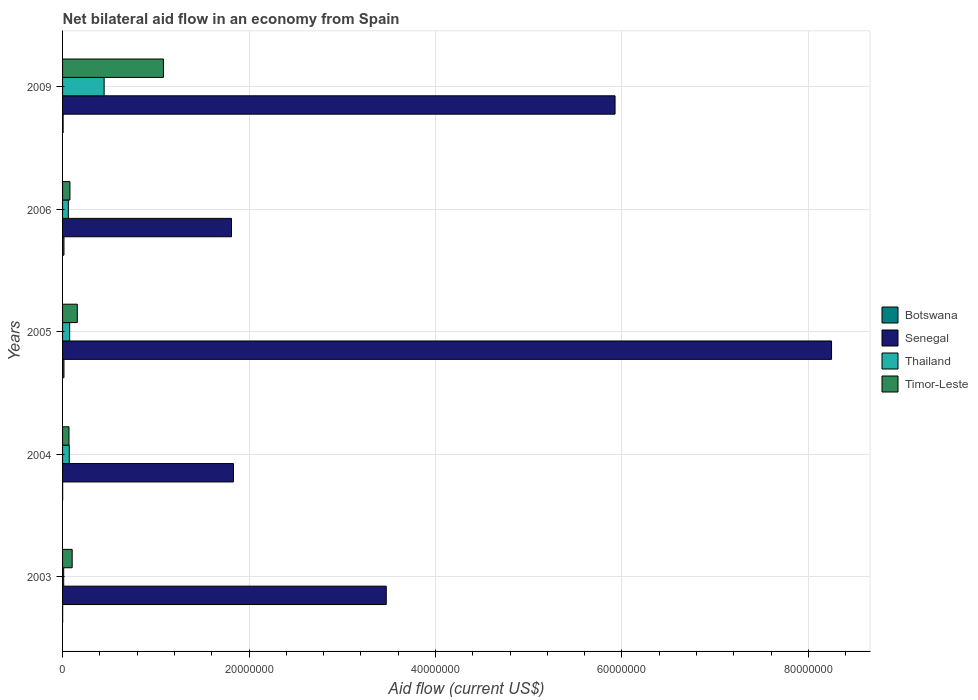How many groups of bars are there?
Provide a succinct answer. 5. Are the number of bars per tick equal to the number of legend labels?
Your response must be concise. Yes. Are the number of bars on each tick of the Y-axis equal?
Your answer should be compact. Yes. How many bars are there on the 5th tick from the top?
Offer a very short reply. 4. What is the net bilateral aid flow in Senegal in 2005?
Give a very brief answer. 8.25e+07. Across all years, what is the maximum net bilateral aid flow in Timor-Leste?
Keep it short and to the point. 1.08e+07. Across all years, what is the minimum net bilateral aid flow in Senegal?
Keep it short and to the point. 1.81e+07. What is the total net bilateral aid flow in Botswana in the graph?
Ensure brevity in your answer.  3.80e+05. What is the difference between the net bilateral aid flow in Senegal in 2006 and that in 2009?
Offer a terse response. -4.11e+07. What is the difference between the net bilateral aid flow in Thailand in 2009 and the net bilateral aid flow in Timor-Leste in 2003?
Your answer should be very brief. 3.43e+06. What is the average net bilateral aid flow in Senegal per year?
Your answer should be very brief. 4.26e+07. In the year 2005, what is the difference between the net bilateral aid flow in Senegal and net bilateral aid flow in Thailand?
Keep it short and to the point. 8.17e+07. What is the ratio of the net bilateral aid flow in Senegal in 2003 to that in 2006?
Offer a very short reply. 1.92. Is the net bilateral aid flow in Thailand in 2003 less than that in 2005?
Offer a terse response. Yes. Is the difference between the net bilateral aid flow in Senegal in 2003 and 2009 greater than the difference between the net bilateral aid flow in Thailand in 2003 and 2009?
Make the answer very short. No. What is the difference between the highest and the second highest net bilateral aid flow in Senegal?
Offer a very short reply. 2.32e+07. What is the difference between the highest and the lowest net bilateral aid flow in Timor-Leste?
Ensure brevity in your answer.  1.01e+07. In how many years, is the net bilateral aid flow in Timor-Leste greater than the average net bilateral aid flow in Timor-Leste taken over all years?
Provide a succinct answer. 1. Is it the case that in every year, the sum of the net bilateral aid flow in Botswana and net bilateral aid flow in Timor-Leste is greater than the sum of net bilateral aid flow in Senegal and net bilateral aid flow in Thailand?
Ensure brevity in your answer.  No. What does the 2nd bar from the top in 2004 represents?
Your answer should be compact. Thailand. What does the 1st bar from the bottom in 2004 represents?
Make the answer very short. Botswana. How many years are there in the graph?
Offer a very short reply. 5. What is the difference between two consecutive major ticks on the X-axis?
Offer a terse response. 2.00e+07. Are the values on the major ticks of X-axis written in scientific E-notation?
Give a very brief answer. No. How are the legend labels stacked?
Provide a succinct answer. Vertical. What is the title of the graph?
Make the answer very short. Net bilateral aid flow in an economy from Spain. Does "Sri Lanka" appear as one of the legend labels in the graph?
Your answer should be very brief. No. What is the label or title of the X-axis?
Ensure brevity in your answer.  Aid flow (current US$). What is the Aid flow (current US$) in Botswana in 2003?
Your response must be concise. 10000. What is the Aid flow (current US$) in Senegal in 2003?
Keep it short and to the point. 3.47e+07. What is the Aid flow (current US$) in Timor-Leste in 2003?
Ensure brevity in your answer.  1.03e+06. What is the Aid flow (current US$) of Senegal in 2004?
Provide a short and direct response. 1.83e+07. What is the Aid flow (current US$) of Thailand in 2004?
Provide a succinct answer. 7.20e+05. What is the Aid flow (current US$) in Timor-Leste in 2004?
Ensure brevity in your answer.  6.90e+05. What is the Aid flow (current US$) in Botswana in 2005?
Your answer should be compact. 1.50e+05. What is the Aid flow (current US$) of Senegal in 2005?
Offer a terse response. 8.25e+07. What is the Aid flow (current US$) in Thailand in 2005?
Offer a very short reply. 7.60e+05. What is the Aid flow (current US$) in Timor-Leste in 2005?
Make the answer very short. 1.58e+06. What is the Aid flow (current US$) of Senegal in 2006?
Provide a succinct answer. 1.81e+07. What is the Aid flow (current US$) in Thailand in 2006?
Your answer should be compact. 6.20e+05. What is the Aid flow (current US$) in Timor-Leste in 2006?
Give a very brief answer. 7.90e+05. What is the Aid flow (current US$) in Senegal in 2009?
Make the answer very short. 5.93e+07. What is the Aid flow (current US$) in Thailand in 2009?
Offer a terse response. 4.46e+06. What is the Aid flow (current US$) of Timor-Leste in 2009?
Your answer should be very brief. 1.08e+07. Across all years, what is the maximum Aid flow (current US$) of Botswana?
Ensure brevity in your answer.  1.50e+05. Across all years, what is the maximum Aid flow (current US$) in Senegal?
Provide a succinct answer. 8.25e+07. Across all years, what is the maximum Aid flow (current US$) of Thailand?
Ensure brevity in your answer.  4.46e+06. Across all years, what is the maximum Aid flow (current US$) in Timor-Leste?
Offer a terse response. 1.08e+07. Across all years, what is the minimum Aid flow (current US$) in Senegal?
Your answer should be compact. 1.81e+07. Across all years, what is the minimum Aid flow (current US$) of Thailand?
Make the answer very short. 1.20e+05. Across all years, what is the minimum Aid flow (current US$) in Timor-Leste?
Your answer should be compact. 6.90e+05. What is the total Aid flow (current US$) of Botswana in the graph?
Provide a succinct answer. 3.80e+05. What is the total Aid flow (current US$) in Senegal in the graph?
Provide a short and direct response. 2.13e+08. What is the total Aid flow (current US$) of Thailand in the graph?
Ensure brevity in your answer.  6.68e+06. What is the total Aid flow (current US$) of Timor-Leste in the graph?
Keep it short and to the point. 1.49e+07. What is the difference between the Aid flow (current US$) of Senegal in 2003 and that in 2004?
Your answer should be very brief. 1.64e+07. What is the difference between the Aid flow (current US$) in Thailand in 2003 and that in 2004?
Your response must be concise. -6.00e+05. What is the difference between the Aid flow (current US$) of Timor-Leste in 2003 and that in 2004?
Your response must be concise. 3.40e+05. What is the difference between the Aid flow (current US$) of Botswana in 2003 and that in 2005?
Your answer should be very brief. -1.40e+05. What is the difference between the Aid flow (current US$) in Senegal in 2003 and that in 2005?
Offer a terse response. -4.78e+07. What is the difference between the Aid flow (current US$) in Thailand in 2003 and that in 2005?
Make the answer very short. -6.40e+05. What is the difference between the Aid flow (current US$) of Timor-Leste in 2003 and that in 2005?
Give a very brief answer. -5.50e+05. What is the difference between the Aid flow (current US$) in Botswana in 2003 and that in 2006?
Offer a terse response. -1.40e+05. What is the difference between the Aid flow (current US$) of Senegal in 2003 and that in 2006?
Provide a succinct answer. 1.66e+07. What is the difference between the Aid flow (current US$) in Thailand in 2003 and that in 2006?
Ensure brevity in your answer.  -5.00e+05. What is the difference between the Aid flow (current US$) in Timor-Leste in 2003 and that in 2006?
Your answer should be compact. 2.40e+05. What is the difference between the Aid flow (current US$) of Senegal in 2003 and that in 2009?
Provide a succinct answer. -2.45e+07. What is the difference between the Aid flow (current US$) of Thailand in 2003 and that in 2009?
Provide a succinct answer. -4.34e+06. What is the difference between the Aid flow (current US$) in Timor-Leste in 2003 and that in 2009?
Your answer should be compact. -9.79e+06. What is the difference between the Aid flow (current US$) in Botswana in 2004 and that in 2005?
Ensure brevity in your answer.  -1.40e+05. What is the difference between the Aid flow (current US$) of Senegal in 2004 and that in 2005?
Keep it short and to the point. -6.42e+07. What is the difference between the Aid flow (current US$) in Thailand in 2004 and that in 2005?
Provide a succinct answer. -4.00e+04. What is the difference between the Aid flow (current US$) of Timor-Leste in 2004 and that in 2005?
Give a very brief answer. -8.90e+05. What is the difference between the Aid flow (current US$) in Timor-Leste in 2004 and that in 2006?
Provide a succinct answer. -1.00e+05. What is the difference between the Aid flow (current US$) in Senegal in 2004 and that in 2009?
Make the answer very short. -4.09e+07. What is the difference between the Aid flow (current US$) of Thailand in 2004 and that in 2009?
Your answer should be very brief. -3.74e+06. What is the difference between the Aid flow (current US$) of Timor-Leste in 2004 and that in 2009?
Make the answer very short. -1.01e+07. What is the difference between the Aid flow (current US$) of Botswana in 2005 and that in 2006?
Your answer should be compact. 0. What is the difference between the Aid flow (current US$) of Senegal in 2005 and that in 2006?
Make the answer very short. 6.44e+07. What is the difference between the Aid flow (current US$) in Timor-Leste in 2005 and that in 2006?
Offer a very short reply. 7.90e+05. What is the difference between the Aid flow (current US$) of Botswana in 2005 and that in 2009?
Provide a short and direct response. 9.00e+04. What is the difference between the Aid flow (current US$) in Senegal in 2005 and that in 2009?
Your response must be concise. 2.32e+07. What is the difference between the Aid flow (current US$) of Thailand in 2005 and that in 2009?
Keep it short and to the point. -3.70e+06. What is the difference between the Aid flow (current US$) in Timor-Leste in 2005 and that in 2009?
Provide a succinct answer. -9.24e+06. What is the difference between the Aid flow (current US$) of Senegal in 2006 and that in 2009?
Your answer should be compact. -4.11e+07. What is the difference between the Aid flow (current US$) of Thailand in 2006 and that in 2009?
Your response must be concise. -3.84e+06. What is the difference between the Aid flow (current US$) of Timor-Leste in 2006 and that in 2009?
Provide a short and direct response. -1.00e+07. What is the difference between the Aid flow (current US$) in Botswana in 2003 and the Aid flow (current US$) in Senegal in 2004?
Offer a very short reply. -1.83e+07. What is the difference between the Aid flow (current US$) in Botswana in 2003 and the Aid flow (current US$) in Thailand in 2004?
Provide a short and direct response. -7.10e+05. What is the difference between the Aid flow (current US$) of Botswana in 2003 and the Aid flow (current US$) of Timor-Leste in 2004?
Provide a short and direct response. -6.80e+05. What is the difference between the Aid flow (current US$) in Senegal in 2003 and the Aid flow (current US$) in Thailand in 2004?
Make the answer very short. 3.40e+07. What is the difference between the Aid flow (current US$) of Senegal in 2003 and the Aid flow (current US$) of Timor-Leste in 2004?
Your answer should be very brief. 3.40e+07. What is the difference between the Aid flow (current US$) of Thailand in 2003 and the Aid flow (current US$) of Timor-Leste in 2004?
Offer a terse response. -5.70e+05. What is the difference between the Aid flow (current US$) in Botswana in 2003 and the Aid flow (current US$) in Senegal in 2005?
Offer a terse response. -8.25e+07. What is the difference between the Aid flow (current US$) of Botswana in 2003 and the Aid flow (current US$) of Thailand in 2005?
Offer a terse response. -7.50e+05. What is the difference between the Aid flow (current US$) of Botswana in 2003 and the Aid flow (current US$) of Timor-Leste in 2005?
Give a very brief answer. -1.57e+06. What is the difference between the Aid flow (current US$) of Senegal in 2003 and the Aid flow (current US$) of Thailand in 2005?
Give a very brief answer. 3.40e+07. What is the difference between the Aid flow (current US$) in Senegal in 2003 and the Aid flow (current US$) in Timor-Leste in 2005?
Ensure brevity in your answer.  3.31e+07. What is the difference between the Aid flow (current US$) in Thailand in 2003 and the Aid flow (current US$) in Timor-Leste in 2005?
Give a very brief answer. -1.46e+06. What is the difference between the Aid flow (current US$) of Botswana in 2003 and the Aid flow (current US$) of Senegal in 2006?
Provide a succinct answer. -1.81e+07. What is the difference between the Aid flow (current US$) in Botswana in 2003 and the Aid flow (current US$) in Thailand in 2006?
Your answer should be very brief. -6.10e+05. What is the difference between the Aid flow (current US$) of Botswana in 2003 and the Aid flow (current US$) of Timor-Leste in 2006?
Ensure brevity in your answer.  -7.80e+05. What is the difference between the Aid flow (current US$) in Senegal in 2003 and the Aid flow (current US$) in Thailand in 2006?
Provide a short and direct response. 3.41e+07. What is the difference between the Aid flow (current US$) of Senegal in 2003 and the Aid flow (current US$) of Timor-Leste in 2006?
Offer a terse response. 3.39e+07. What is the difference between the Aid flow (current US$) in Thailand in 2003 and the Aid flow (current US$) in Timor-Leste in 2006?
Your response must be concise. -6.70e+05. What is the difference between the Aid flow (current US$) of Botswana in 2003 and the Aid flow (current US$) of Senegal in 2009?
Provide a succinct answer. -5.92e+07. What is the difference between the Aid flow (current US$) of Botswana in 2003 and the Aid flow (current US$) of Thailand in 2009?
Provide a succinct answer. -4.45e+06. What is the difference between the Aid flow (current US$) in Botswana in 2003 and the Aid flow (current US$) in Timor-Leste in 2009?
Make the answer very short. -1.08e+07. What is the difference between the Aid flow (current US$) in Senegal in 2003 and the Aid flow (current US$) in Thailand in 2009?
Ensure brevity in your answer.  3.03e+07. What is the difference between the Aid flow (current US$) of Senegal in 2003 and the Aid flow (current US$) of Timor-Leste in 2009?
Your answer should be compact. 2.39e+07. What is the difference between the Aid flow (current US$) of Thailand in 2003 and the Aid flow (current US$) of Timor-Leste in 2009?
Ensure brevity in your answer.  -1.07e+07. What is the difference between the Aid flow (current US$) in Botswana in 2004 and the Aid flow (current US$) in Senegal in 2005?
Provide a short and direct response. -8.25e+07. What is the difference between the Aid flow (current US$) of Botswana in 2004 and the Aid flow (current US$) of Thailand in 2005?
Offer a very short reply. -7.50e+05. What is the difference between the Aid flow (current US$) of Botswana in 2004 and the Aid flow (current US$) of Timor-Leste in 2005?
Keep it short and to the point. -1.57e+06. What is the difference between the Aid flow (current US$) of Senegal in 2004 and the Aid flow (current US$) of Thailand in 2005?
Provide a succinct answer. 1.76e+07. What is the difference between the Aid flow (current US$) in Senegal in 2004 and the Aid flow (current US$) in Timor-Leste in 2005?
Your answer should be very brief. 1.68e+07. What is the difference between the Aid flow (current US$) in Thailand in 2004 and the Aid flow (current US$) in Timor-Leste in 2005?
Make the answer very short. -8.60e+05. What is the difference between the Aid flow (current US$) in Botswana in 2004 and the Aid flow (current US$) in Senegal in 2006?
Make the answer very short. -1.81e+07. What is the difference between the Aid flow (current US$) of Botswana in 2004 and the Aid flow (current US$) of Thailand in 2006?
Provide a short and direct response. -6.10e+05. What is the difference between the Aid flow (current US$) of Botswana in 2004 and the Aid flow (current US$) of Timor-Leste in 2006?
Ensure brevity in your answer.  -7.80e+05. What is the difference between the Aid flow (current US$) in Senegal in 2004 and the Aid flow (current US$) in Thailand in 2006?
Your response must be concise. 1.77e+07. What is the difference between the Aid flow (current US$) in Senegal in 2004 and the Aid flow (current US$) in Timor-Leste in 2006?
Offer a terse response. 1.75e+07. What is the difference between the Aid flow (current US$) in Thailand in 2004 and the Aid flow (current US$) in Timor-Leste in 2006?
Ensure brevity in your answer.  -7.00e+04. What is the difference between the Aid flow (current US$) of Botswana in 2004 and the Aid flow (current US$) of Senegal in 2009?
Your answer should be very brief. -5.92e+07. What is the difference between the Aid flow (current US$) of Botswana in 2004 and the Aid flow (current US$) of Thailand in 2009?
Give a very brief answer. -4.45e+06. What is the difference between the Aid flow (current US$) in Botswana in 2004 and the Aid flow (current US$) in Timor-Leste in 2009?
Your answer should be very brief. -1.08e+07. What is the difference between the Aid flow (current US$) of Senegal in 2004 and the Aid flow (current US$) of Thailand in 2009?
Keep it short and to the point. 1.39e+07. What is the difference between the Aid flow (current US$) in Senegal in 2004 and the Aid flow (current US$) in Timor-Leste in 2009?
Ensure brevity in your answer.  7.51e+06. What is the difference between the Aid flow (current US$) in Thailand in 2004 and the Aid flow (current US$) in Timor-Leste in 2009?
Provide a succinct answer. -1.01e+07. What is the difference between the Aid flow (current US$) of Botswana in 2005 and the Aid flow (current US$) of Senegal in 2006?
Your answer should be compact. -1.80e+07. What is the difference between the Aid flow (current US$) in Botswana in 2005 and the Aid flow (current US$) in Thailand in 2006?
Ensure brevity in your answer.  -4.70e+05. What is the difference between the Aid flow (current US$) of Botswana in 2005 and the Aid flow (current US$) of Timor-Leste in 2006?
Give a very brief answer. -6.40e+05. What is the difference between the Aid flow (current US$) in Senegal in 2005 and the Aid flow (current US$) in Thailand in 2006?
Keep it short and to the point. 8.19e+07. What is the difference between the Aid flow (current US$) in Senegal in 2005 and the Aid flow (current US$) in Timor-Leste in 2006?
Your answer should be compact. 8.17e+07. What is the difference between the Aid flow (current US$) of Botswana in 2005 and the Aid flow (current US$) of Senegal in 2009?
Make the answer very short. -5.91e+07. What is the difference between the Aid flow (current US$) of Botswana in 2005 and the Aid flow (current US$) of Thailand in 2009?
Offer a terse response. -4.31e+06. What is the difference between the Aid flow (current US$) in Botswana in 2005 and the Aid flow (current US$) in Timor-Leste in 2009?
Offer a very short reply. -1.07e+07. What is the difference between the Aid flow (current US$) of Senegal in 2005 and the Aid flow (current US$) of Thailand in 2009?
Ensure brevity in your answer.  7.80e+07. What is the difference between the Aid flow (current US$) of Senegal in 2005 and the Aid flow (current US$) of Timor-Leste in 2009?
Keep it short and to the point. 7.17e+07. What is the difference between the Aid flow (current US$) in Thailand in 2005 and the Aid flow (current US$) in Timor-Leste in 2009?
Provide a short and direct response. -1.01e+07. What is the difference between the Aid flow (current US$) in Botswana in 2006 and the Aid flow (current US$) in Senegal in 2009?
Keep it short and to the point. -5.91e+07. What is the difference between the Aid flow (current US$) of Botswana in 2006 and the Aid flow (current US$) of Thailand in 2009?
Your answer should be very brief. -4.31e+06. What is the difference between the Aid flow (current US$) of Botswana in 2006 and the Aid flow (current US$) of Timor-Leste in 2009?
Provide a short and direct response. -1.07e+07. What is the difference between the Aid flow (current US$) in Senegal in 2006 and the Aid flow (current US$) in Thailand in 2009?
Keep it short and to the point. 1.37e+07. What is the difference between the Aid flow (current US$) of Senegal in 2006 and the Aid flow (current US$) of Timor-Leste in 2009?
Provide a short and direct response. 7.30e+06. What is the difference between the Aid flow (current US$) of Thailand in 2006 and the Aid flow (current US$) of Timor-Leste in 2009?
Offer a very short reply. -1.02e+07. What is the average Aid flow (current US$) of Botswana per year?
Offer a terse response. 7.60e+04. What is the average Aid flow (current US$) of Senegal per year?
Make the answer very short. 4.26e+07. What is the average Aid flow (current US$) of Thailand per year?
Your answer should be very brief. 1.34e+06. What is the average Aid flow (current US$) in Timor-Leste per year?
Make the answer very short. 2.98e+06. In the year 2003, what is the difference between the Aid flow (current US$) in Botswana and Aid flow (current US$) in Senegal?
Keep it short and to the point. -3.47e+07. In the year 2003, what is the difference between the Aid flow (current US$) of Botswana and Aid flow (current US$) of Thailand?
Give a very brief answer. -1.10e+05. In the year 2003, what is the difference between the Aid flow (current US$) in Botswana and Aid flow (current US$) in Timor-Leste?
Offer a very short reply. -1.02e+06. In the year 2003, what is the difference between the Aid flow (current US$) in Senegal and Aid flow (current US$) in Thailand?
Keep it short and to the point. 3.46e+07. In the year 2003, what is the difference between the Aid flow (current US$) of Senegal and Aid flow (current US$) of Timor-Leste?
Give a very brief answer. 3.37e+07. In the year 2003, what is the difference between the Aid flow (current US$) of Thailand and Aid flow (current US$) of Timor-Leste?
Provide a short and direct response. -9.10e+05. In the year 2004, what is the difference between the Aid flow (current US$) of Botswana and Aid flow (current US$) of Senegal?
Give a very brief answer. -1.83e+07. In the year 2004, what is the difference between the Aid flow (current US$) in Botswana and Aid flow (current US$) in Thailand?
Provide a succinct answer. -7.10e+05. In the year 2004, what is the difference between the Aid flow (current US$) in Botswana and Aid flow (current US$) in Timor-Leste?
Offer a very short reply. -6.80e+05. In the year 2004, what is the difference between the Aid flow (current US$) of Senegal and Aid flow (current US$) of Thailand?
Provide a succinct answer. 1.76e+07. In the year 2004, what is the difference between the Aid flow (current US$) in Senegal and Aid flow (current US$) in Timor-Leste?
Your response must be concise. 1.76e+07. In the year 2004, what is the difference between the Aid flow (current US$) in Thailand and Aid flow (current US$) in Timor-Leste?
Provide a short and direct response. 3.00e+04. In the year 2005, what is the difference between the Aid flow (current US$) in Botswana and Aid flow (current US$) in Senegal?
Offer a very short reply. -8.23e+07. In the year 2005, what is the difference between the Aid flow (current US$) of Botswana and Aid flow (current US$) of Thailand?
Your response must be concise. -6.10e+05. In the year 2005, what is the difference between the Aid flow (current US$) of Botswana and Aid flow (current US$) of Timor-Leste?
Provide a succinct answer. -1.43e+06. In the year 2005, what is the difference between the Aid flow (current US$) in Senegal and Aid flow (current US$) in Thailand?
Offer a very short reply. 8.17e+07. In the year 2005, what is the difference between the Aid flow (current US$) of Senegal and Aid flow (current US$) of Timor-Leste?
Your answer should be very brief. 8.09e+07. In the year 2005, what is the difference between the Aid flow (current US$) of Thailand and Aid flow (current US$) of Timor-Leste?
Keep it short and to the point. -8.20e+05. In the year 2006, what is the difference between the Aid flow (current US$) of Botswana and Aid flow (current US$) of Senegal?
Provide a short and direct response. -1.80e+07. In the year 2006, what is the difference between the Aid flow (current US$) in Botswana and Aid flow (current US$) in Thailand?
Make the answer very short. -4.70e+05. In the year 2006, what is the difference between the Aid flow (current US$) in Botswana and Aid flow (current US$) in Timor-Leste?
Ensure brevity in your answer.  -6.40e+05. In the year 2006, what is the difference between the Aid flow (current US$) in Senegal and Aid flow (current US$) in Thailand?
Provide a succinct answer. 1.75e+07. In the year 2006, what is the difference between the Aid flow (current US$) of Senegal and Aid flow (current US$) of Timor-Leste?
Your answer should be compact. 1.73e+07. In the year 2006, what is the difference between the Aid flow (current US$) in Thailand and Aid flow (current US$) in Timor-Leste?
Give a very brief answer. -1.70e+05. In the year 2009, what is the difference between the Aid flow (current US$) of Botswana and Aid flow (current US$) of Senegal?
Offer a terse response. -5.92e+07. In the year 2009, what is the difference between the Aid flow (current US$) in Botswana and Aid flow (current US$) in Thailand?
Keep it short and to the point. -4.40e+06. In the year 2009, what is the difference between the Aid flow (current US$) in Botswana and Aid flow (current US$) in Timor-Leste?
Offer a very short reply. -1.08e+07. In the year 2009, what is the difference between the Aid flow (current US$) in Senegal and Aid flow (current US$) in Thailand?
Your response must be concise. 5.48e+07. In the year 2009, what is the difference between the Aid flow (current US$) in Senegal and Aid flow (current US$) in Timor-Leste?
Your answer should be very brief. 4.84e+07. In the year 2009, what is the difference between the Aid flow (current US$) in Thailand and Aid flow (current US$) in Timor-Leste?
Give a very brief answer. -6.36e+06. What is the ratio of the Aid flow (current US$) of Botswana in 2003 to that in 2004?
Your response must be concise. 1. What is the ratio of the Aid flow (current US$) in Senegal in 2003 to that in 2004?
Make the answer very short. 1.89. What is the ratio of the Aid flow (current US$) in Timor-Leste in 2003 to that in 2004?
Offer a terse response. 1.49. What is the ratio of the Aid flow (current US$) of Botswana in 2003 to that in 2005?
Make the answer very short. 0.07. What is the ratio of the Aid flow (current US$) of Senegal in 2003 to that in 2005?
Make the answer very short. 0.42. What is the ratio of the Aid flow (current US$) in Thailand in 2003 to that in 2005?
Make the answer very short. 0.16. What is the ratio of the Aid flow (current US$) of Timor-Leste in 2003 to that in 2005?
Give a very brief answer. 0.65. What is the ratio of the Aid flow (current US$) in Botswana in 2003 to that in 2006?
Keep it short and to the point. 0.07. What is the ratio of the Aid flow (current US$) of Senegal in 2003 to that in 2006?
Keep it short and to the point. 1.92. What is the ratio of the Aid flow (current US$) of Thailand in 2003 to that in 2006?
Give a very brief answer. 0.19. What is the ratio of the Aid flow (current US$) in Timor-Leste in 2003 to that in 2006?
Give a very brief answer. 1.3. What is the ratio of the Aid flow (current US$) of Botswana in 2003 to that in 2009?
Offer a very short reply. 0.17. What is the ratio of the Aid flow (current US$) of Senegal in 2003 to that in 2009?
Offer a very short reply. 0.59. What is the ratio of the Aid flow (current US$) of Thailand in 2003 to that in 2009?
Give a very brief answer. 0.03. What is the ratio of the Aid flow (current US$) in Timor-Leste in 2003 to that in 2009?
Keep it short and to the point. 0.1. What is the ratio of the Aid flow (current US$) of Botswana in 2004 to that in 2005?
Make the answer very short. 0.07. What is the ratio of the Aid flow (current US$) in Senegal in 2004 to that in 2005?
Your answer should be very brief. 0.22. What is the ratio of the Aid flow (current US$) of Thailand in 2004 to that in 2005?
Your answer should be compact. 0.95. What is the ratio of the Aid flow (current US$) of Timor-Leste in 2004 to that in 2005?
Offer a terse response. 0.44. What is the ratio of the Aid flow (current US$) of Botswana in 2004 to that in 2006?
Your answer should be very brief. 0.07. What is the ratio of the Aid flow (current US$) in Senegal in 2004 to that in 2006?
Ensure brevity in your answer.  1.01. What is the ratio of the Aid flow (current US$) of Thailand in 2004 to that in 2006?
Offer a terse response. 1.16. What is the ratio of the Aid flow (current US$) of Timor-Leste in 2004 to that in 2006?
Keep it short and to the point. 0.87. What is the ratio of the Aid flow (current US$) in Botswana in 2004 to that in 2009?
Offer a very short reply. 0.17. What is the ratio of the Aid flow (current US$) in Senegal in 2004 to that in 2009?
Provide a short and direct response. 0.31. What is the ratio of the Aid flow (current US$) in Thailand in 2004 to that in 2009?
Offer a very short reply. 0.16. What is the ratio of the Aid flow (current US$) of Timor-Leste in 2004 to that in 2009?
Keep it short and to the point. 0.06. What is the ratio of the Aid flow (current US$) in Botswana in 2005 to that in 2006?
Ensure brevity in your answer.  1. What is the ratio of the Aid flow (current US$) of Senegal in 2005 to that in 2006?
Keep it short and to the point. 4.55. What is the ratio of the Aid flow (current US$) in Thailand in 2005 to that in 2006?
Your response must be concise. 1.23. What is the ratio of the Aid flow (current US$) of Timor-Leste in 2005 to that in 2006?
Make the answer very short. 2. What is the ratio of the Aid flow (current US$) of Senegal in 2005 to that in 2009?
Keep it short and to the point. 1.39. What is the ratio of the Aid flow (current US$) in Thailand in 2005 to that in 2009?
Keep it short and to the point. 0.17. What is the ratio of the Aid flow (current US$) in Timor-Leste in 2005 to that in 2009?
Provide a short and direct response. 0.15. What is the ratio of the Aid flow (current US$) of Botswana in 2006 to that in 2009?
Provide a short and direct response. 2.5. What is the ratio of the Aid flow (current US$) in Senegal in 2006 to that in 2009?
Keep it short and to the point. 0.31. What is the ratio of the Aid flow (current US$) of Thailand in 2006 to that in 2009?
Your answer should be very brief. 0.14. What is the ratio of the Aid flow (current US$) of Timor-Leste in 2006 to that in 2009?
Your answer should be very brief. 0.07. What is the difference between the highest and the second highest Aid flow (current US$) of Senegal?
Your response must be concise. 2.32e+07. What is the difference between the highest and the second highest Aid flow (current US$) of Thailand?
Ensure brevity in your answer.  3.70e+06. What is the difference between the highest and the second highest Aid flow (current US$) of Timor-Leste?
Your answer should be compact. 9.24e+06. What is the difference between the highest and the lowest Aid flow (current US$) in Botswana?
Keep it short and to the point. 1.40e+05. What is the difference between the highest and the lowest Aid flow (current US$) of Senegal?
Provide a short and direct response. 6.44e+07. What is the difference between the highest and the lowest Aid flow (current US$) of Thailand?
Your answer should be very brief. 4.34e+06. What is the difference between the highest and the lowest Aid flow (current US$) of Timor-Leste?
Your answer should be very brief. 1.01e+07. 